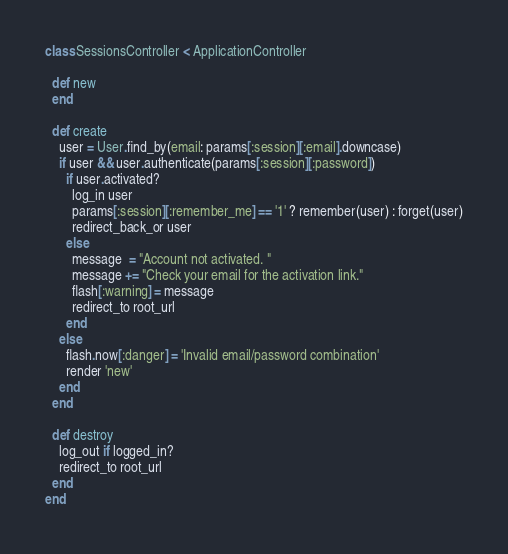Convert code to text. <code><loc_0><loc_0><loc_500><loc_500><_Ruby_>class SessionsController < ApplicationController

  def new
  end

  def create
    user = User.find_by(email: params[:session][:email].downcase)
    if user && user.authenticate(params[:session][:password])
      if user.activated?
        log_in user
        params[:session][:remember_me] == '1' ? remember(user) : forget(user)
        redirect_back_or user
      else
        message  = "Account not activated. "
        message += "Check your email for the activation link."
        flash[:warning] = message
        redirect_to root_url
      end
    else
      flash.now[:danger] = 'Invalid email/password combination'
      render 'new'
    end
  end

  def destroy  	
  	log_out if logged_in?
  	redirect_to root_url
  end
end
</code> 